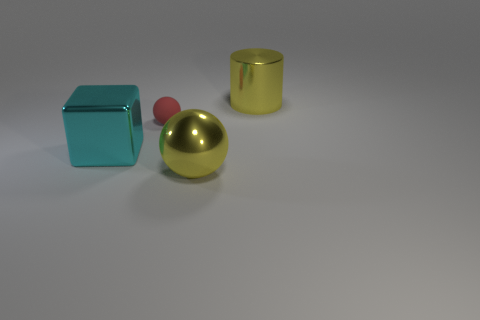Can you infer the texture of the objects based on their appearance? Certainly, the objects appear to have smooth and highly reflective surfaces, indicative of a polished texture. The spherical object and the cylinder seem to have a flawless metallic finish, while the cube has a finish that could suggest a smooth and possibly translucent material. What about the sizes of these objects relative to each other? The objects display a contrasting range of sizes; the large cylinder and the sphere are similar in height, while the cube is slightly smaller in scale. The small red sphere is significantly smaller compared to the other shapes, emphasizing the variety of scales in this arrangement. 